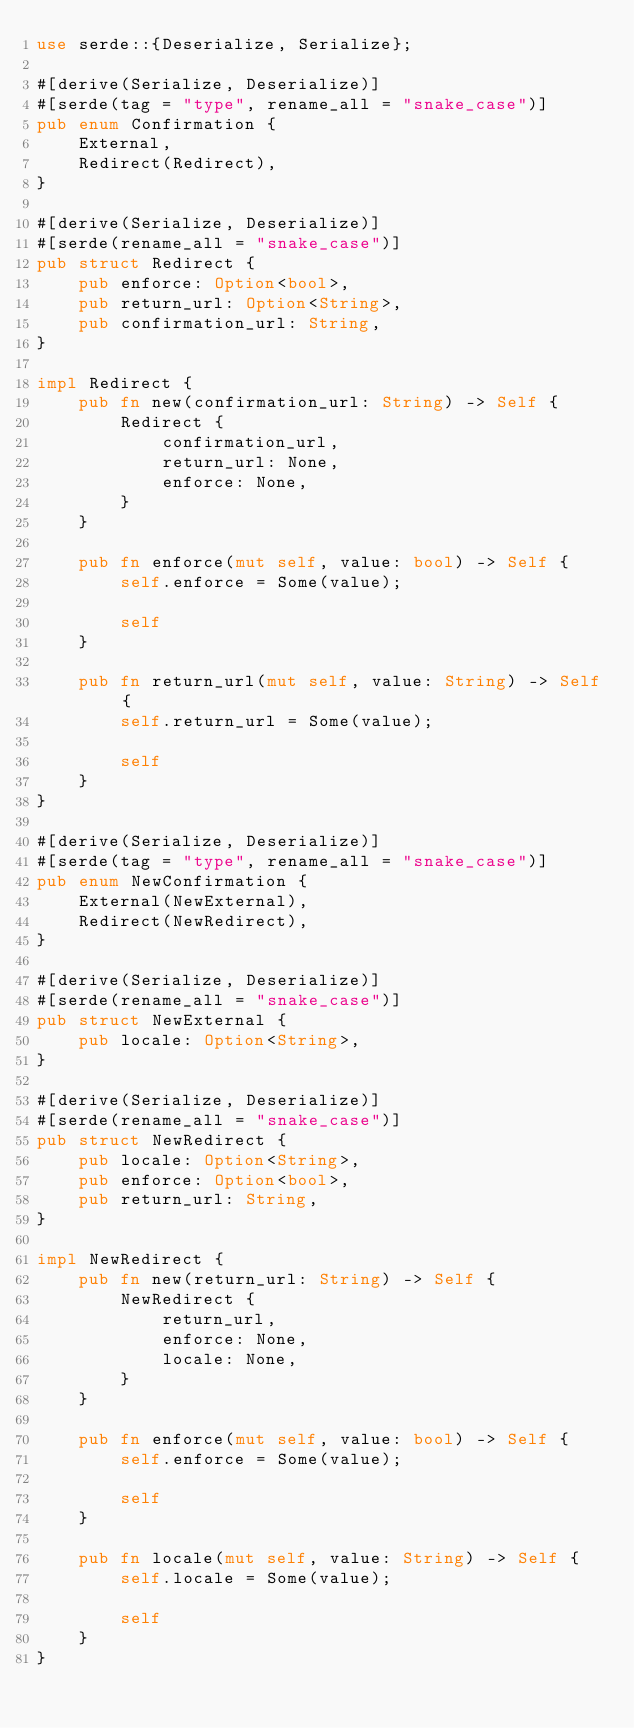Convert code to text. <code><loc_0><loc_0><loc_500><loc_500><_Rust_>use serde::{Deserialize, Serialize};

#[derive(Serialize, Deserialize)]
#[serde(tag = "type", rename_all = "snake_case")]
pub enum Confirmation {
    External,
    Redirect(Redirect),
}

#[derive(Serialize, Deserialize)]
#[serde(rename_all = "snake_case")]
pub struct Redirect {
    pub enforce: Option<bool>,
    pub return_url: Option<String>,
    pub confirmation_url: String,
}

impl Redirect {
    pub fn new(confirmation_url: String) -> Self {
        Redirect {
            confirmation_url,
            return_url: None,
            enforce: None,
        }
    }

    pub fn enforce(mut self, value: bool) -> Self {
        self.enforce = Some(value);

        self
    }

    pub fn return_url(mut self, value: String) -> Self {
        self.return_url = Some(value);

        self
    }
}

#[derive(Serialize, Deserialize)]
#[serde(tag = "type", rename_all = "snake_case")]
pub enum NewConfirmation {
    External(NewExternal),
    Redirect(NewRedirect),
}

#[derive(Serialize, Deserialize)]
#[serde(rename_all = "snake_case")]
pub struct NewExternal {
    pub locale: Option<String>,
}

#[derive(Serialize, Deserialize)]
#[serde(rename_all = "snake_case")]
pub struct NewRedirect {
    pub locale: Option<String>,
    pub enforce: Option<bool>,
    pub return_url: String,
}

impl NewRedirect {
    pub fn new(return_url: String) -> Self {
        NewRedirect {
            return_url,
            enforce: None,
            locale: None,
        }
    }

    pub fn enforce(mut self, value: bool) -> Self {
        self.enforce = Some(value);

        self
    }

    pub fn locale(mut self, value: String) -> Self {
        self.locale = Some(value);

        self
    }
}
</code> 